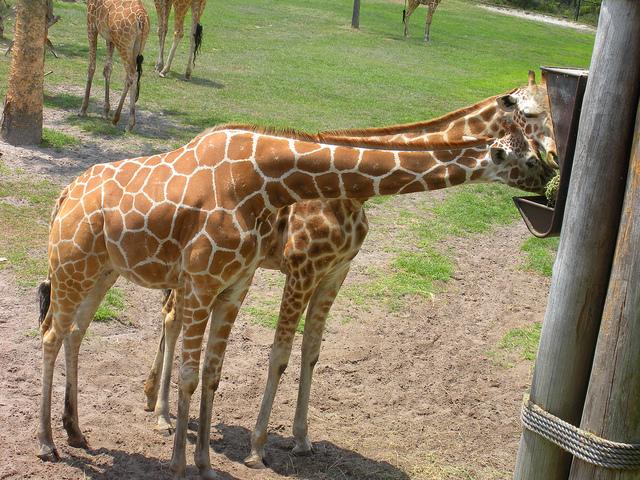Is the animal giraffe?
Give a very brief answer. Yes. What is the relationship in the photo?
Keep it brief. Siblings. What is the giraffe doing?
Write a very short answer. Eating. Why is some of the grass brown?
Give a very brief answer. Dry. 